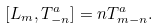Convert formula to latex. <formula><loc_0><loc_0><loc_500><loc_500>[ L _ { m } , T ^ { a } _ { - n } ] = n T ^ { a } _ { m - n } .</formula> 